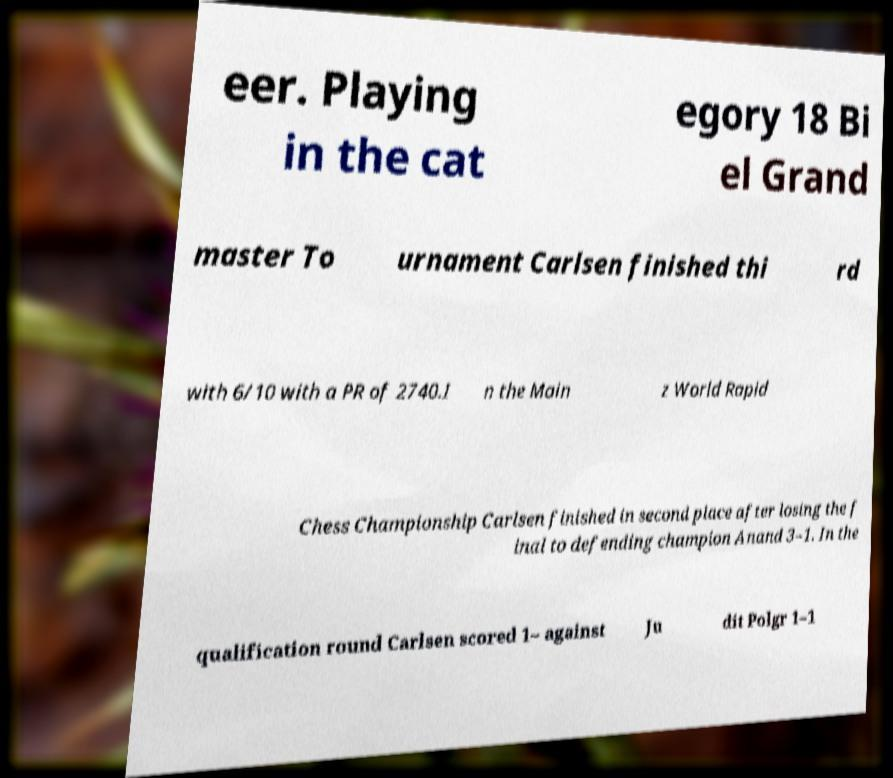Please read and relay the text visible in this image. What does it say? eer. Playing in the cat egory 18 Bi el Grand master To urnament Carlsen finished thi rd with 6/10 with a PR of 2740.I n the Main z World Rapid Chess Championship Carlsen finished in second place after losing the f inal to defending champion Anand 3–1. In the qualification round Carlsen scored 1– against Ju dit Polgr 1–1 